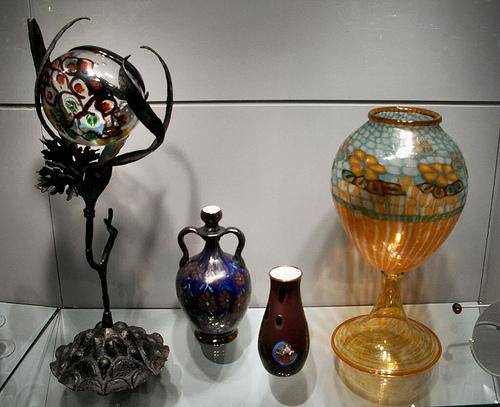Question: what kind of material is seen here?
Choices:
A. Brick.
B. Carpet.
C. Glass.
D. Drywall.
Answer with the letter. Answer: C Question: where was this picture taken?
Choices:
A. The zoo.
B. The park.
C. In a museum.
D. Airport.
Answer with the letter. Answer: C Question: why are these thing on a shelf?
Choices:
A. To display them.
B. For sale.
C. Cleaning.
D. Hide them.
Answer with the letter. Answer: A Question: what pattern do the objects all have?
Choices:
A. Circular.
B. Floral.
C. Gingham.
D. Plaid.
Answer with the letter. Answer: B 